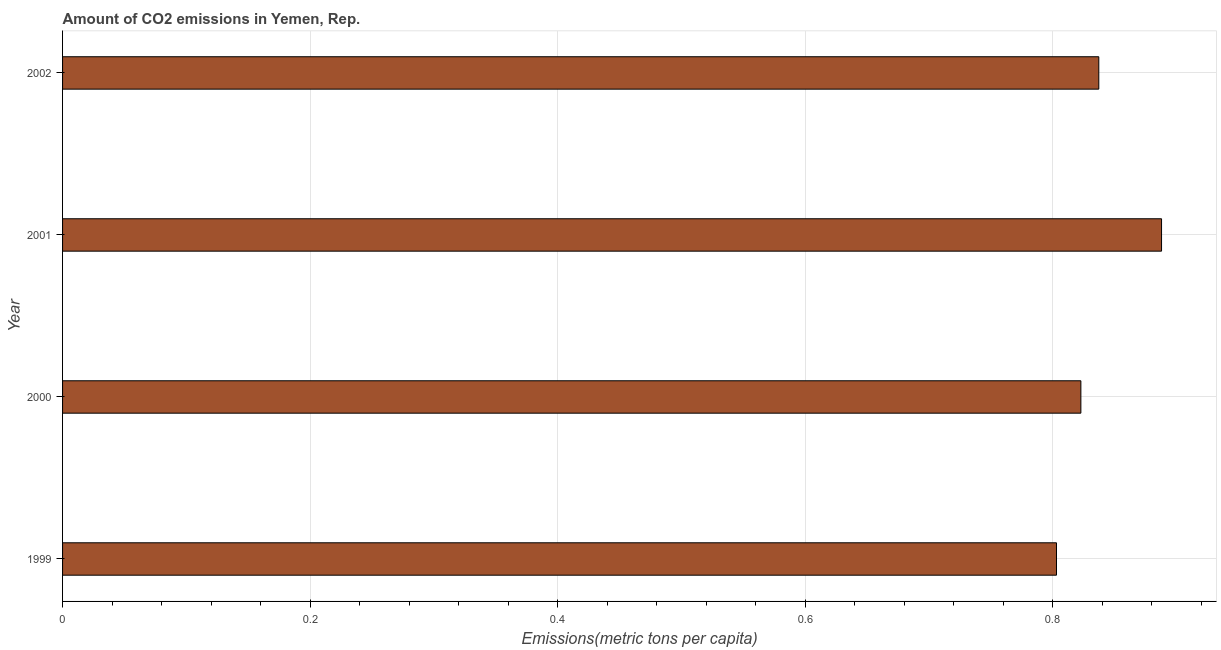Does the graph contain any zero values?
Your answer should be very brief. No. What is the title of the graph?
Make the answer very short. Amount of CO2 emissions in Yemen, Rep. What is the label or title of the X-axis?
Offer a terse response. Emissions(metric tons per capita). What is the amount of co2 emissions in 2002?
Provide a succinct answer. 0.84. Across all years, what is the maximum amount of co2 emissions?
Offer a terse response. 0.89. Across all years, what is the minimum amount of co2 emissions?
Make the answer very short. 0.8. In which year was the amount of co2 emissions minimum?
Keep it short and to the point. 1999. What is the sum of the amount of co2 emissions?
Your response must be concise. 3.35. What is the difference between the amount of co2 emissions in 1999 and 2001?
Make the answer very short. -0.09. What is the average amount of co2 emissions per year?
Your response must be concise. 0.84. What is the median amount of co2 emissions?
Keep it short and to the point. 0.83. Do a majority of the years between 2002 and 2001 (inclusive) have amount of co2 emissions greater than 0.52 metric tons per capita?
Make the answer very short. No. What is the ratio of the amount of co2 emissions in 1999 to that in 2000?
Your answer should be very brief. 0.98. Is the amount of co2 emissions in 1999 less than that in 2002?
Keep it short and to the point. Yes. What is the difference between the highest and the second highest amount of co2 emissions?
Offer a terse response. 0.05. Is the sum of the amount of co2 emissions in 1999 and 2001 greater than the maximum amount of co2 emissions across all years?
Make the answer very short. Yes. In how many years, is the amount of co2 emissions greater than the average amount of co2 emissions taken over all years?
Offer a terse response. 1. How many bars are there?
Provide a short and direct response. 4. Are all the bars in the graph horizontal?
Give a very brief answer. Yes. How many years are there in the graph?
Give a very brief answer. 4. What is the difference between two consecutive major ticks on the X-axis?
Offer a very short reply. 0.2. What is the Emissions(metric tons per capita) in 1999?
Your response must be concise. 0.8. What is the Emissions(metric tons per capita) in 2000?
Your response must be concise. 0.82. What is the Emissions(metric tons per capita) in 2001?
Keep it short and to the point. 0.89. What is the Emissions(metric tons per capita) of 2002?
Provide a short and direct response. 0.84. What is the difference between the Emissions(metric tons per capita) in 1999 and 2000?
Keep it short and to the point. -0.02. What is the difference between the Emissions(metric tons per capita) in 1999 and 2001?
Give a very brief answer. -0.08. What is the difference between the Emissions(metric tons per capita) in 1999 and 2002?
Keep it short and to the point. -0.03. What is the difference between the Emissions(metric tons per capita) in 2000 and 2001?
Give a very brief answer. -0.07. What is the difference between the Emissions(metric tons per capita) in 2000 and 2002?
Your answer should be compact. -0.01. What is the difference between the Emissions(metric tons per capita) in 2001 and 2002?
Your response must be concise. 0.05. What is the ratio of the Emissions(metric tons per capita) in 1999 to that in 2001?
Ensure brevity in your answer.  0.9. What is the ratio of the Emissions(metric tons per capita) in 1999 to that in 2002?
Provide a short and direct response. 0.96. What is the ratio of the Emissions(metric tons per capita) in 2000 to that in 2001?
Your answer should be compact. 0.93. What is the ratio of the Emissions(metric tons per capita) in 2000 to that in 2002?
Provide a short and direct response. 0.98. What is the ratio of the Emissions(metric tons per capita) in 2001 to that in 2002?
Offer a very short reply. 1.06. 